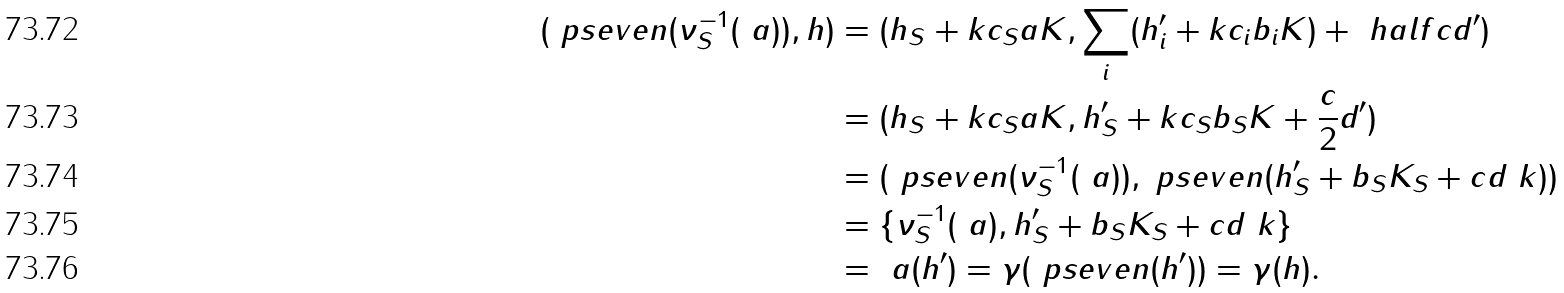<formula> <loc_0><loc_0><loc_500><loc_500>( \ p s e v e n ( \nu _ { S } ^ { - 1 } ( \ a ) ) , h ) & = ( h _ { S } + k c _ { S } a K , \sum _ { i } ( h ^ { \prime } _ { i } + k c _ { i } b _ { i } K ) + \ h a l f c d ^ { \prime } ) \\ & = ( h _ { S } + k c _ { S } a K , h ^ { \prime } _ { S } + k c _ { S } b _ { S } K + \frac { c } { 2 } d ^ { \prime } ) \\ & = ( \ p s e v e n ( \nu _ { S } ^ { - 1 } ( \ a ) ) , \ p s e v e n ( h ^ { \prime } _ { S } + b _ { S } K _ { S } + c d _ { \ } k ) ) \\ & = \{ \nu _ { S } ^ { - 1 } ( \ a ) , h ^ { \prime } _ { S } + b _ { S } K _ { S } + c d _ { \ } k \} \\ & = \ a ( h ^ { \prime } ) = \gamma ( \ p s e v e n ( h ^ { \prime } ) ) = \gamma ( h ) .</formula> 